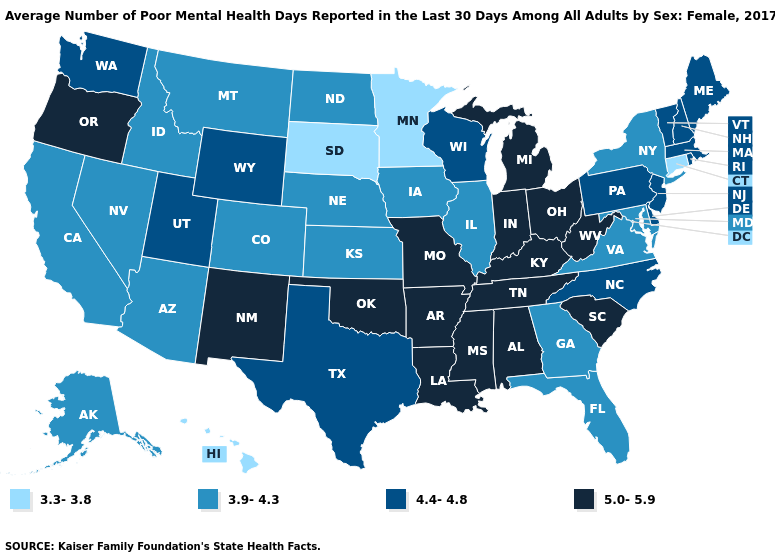What is the value of Florida?
Concise answer only. 3.9-4.3. Which states hav the highest value in the MidWest?
Concise answer only. Indiana, Michigan, Missouri, Ohio. Name the states that have a value in the range 4.4-4.8?
Answer briefly. Delaware, Maine, Massachusetts, New Hampshire, New Jersey, North Carolina, Pennsylvania, Rhode Island, Texas, Utah, Vermont, Washington, Wisconsin, Wyoming. Does the map have missing data?
Keep it brief. No. What is the lowest value in the USA?
Answer briefly. 3.3-3.8. How many symbols are there in the legend?
Concise answer only. 4. Name the states that have a value in the range 3.3-3.8?
Write a very short answer. Connecticut, Hawaii, Minnesota, South Dakota. Name the states that have a value in the range 5.0-5.9?
Answer briefly. Alabama, Arkansas, Indiana, Kentucky, Louisiana, Michigan, Mississippi, Missouri, New Mexico, Ohio, Oklahoma, Oregon, South Carolina, Tennessee, West Virginia. Which states have the lowest value in the USA?
Be succinct. Connecticut, Hawaii, Minnesota, South Dakota. Does Hawaii have a lower value than Minnesota?
Give a very brief answer. No. What is the highest value in the South ?
Write a very short answer. 5.0-5.9. Does the first symbol in the legend represent the smallest category?
Write a very short answer. Yes. What is the value of Oregon?
Answer briefly. 5.0-5.9. Which states hav the highest value in the MidWest?
Write a very short answer. Indiana, Michigan, Missouri, Ohio. What is the highest value in states that border Washington?
Answer briefly. 5.0-5.9. 